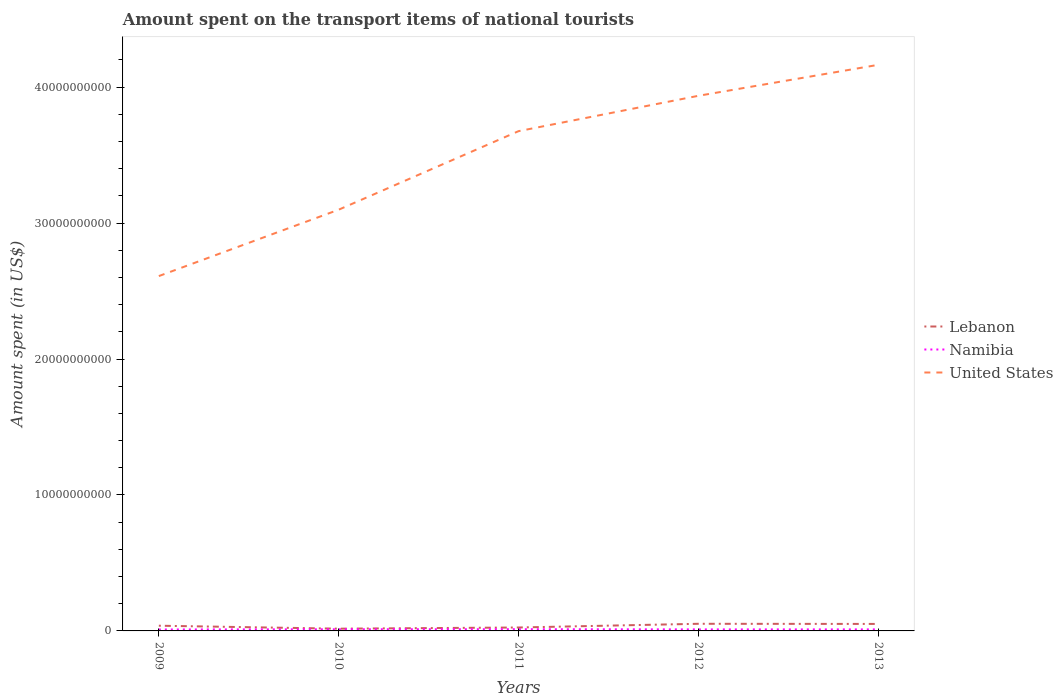Across all years, what is the maximum amount spent on the transport items of national tourists in Namibia?
Offer a very short reply. 1.06e+08. In which year was the amount spent on the transport items of national tourists in United States maximum?
Ensure brevity in your answer.  2009. What is the total amount spent on the transport items of national tourists in United States in the graph?
Offer a terse response. -1.07e+1. What is the difference between the highest and the second highest amount spent on the transport items of national tourists in Namibia?
Give a very brief answer. 2.10e+07. What is the difference between the highest and the lowest amount spent on the transport items of national tourists in United States?
Ensure brevity in your answer.  3. Is the amount spent on the transport items of national tourists in Lebanon strictly greater than the amount spent on the transport items of national tourists in United States over the years?
Make the answer very short. Yes. Are the values on the major ticks of Y-axis written in scientific E-notation?
Your response must be concise. No. Does the graph contain grids?
Make the answer very short. No. How are the legend labels stacked?
Your answer should be very brief. Vertical. What is the title of the graph?
Provide a short and direct response. Amount spent on the transport items of national tourists. Does "Somalia" appear as one of the legend labels in the graph?
Give a very brief answer. No. What is the label or title of the Y-axis?
Provide a succinct answer. Amount spent (in US$). What is the Amount spent (in US$) in Lebanon in 2009?
Give a very brief answer. 3.83e+08. What is the Amount spent (in US$) in Namibia in 2009?
Ensure brevity in your answer.  1.06e+08. What is the Amount spent (in US$) in United States in 2009?
Your answer should be very brief. 2.61e+1. What is the Amount spent (in US$) of Lebanon in 2010?
Your answer should be very brief. 1.65e+08. What is the Amount spent (in US$) in Namibia in 2010?
Ensure brevity in your answer.  1.21e+08. What is the Amount spent (in US$) in United States in 2010?
Your answer should be compact. 3.10e+1. What is the Amount spent (in US$) of Lebanon in 2011?
Offer a terse response. 2.52e+08. What is the Amount spent (in US$) of Namibia in 2011?
Your answer should be compact. 1.27e+08. What is the Amount spent (in US$) of United States in 2011?
Your response must be concise. 3.68e+1. What is the Amount spent (in US$) of Lebanon in 2012?
Give a very brief answer. 5.25e+08. What is the Amount spent (in US$) in Namibia in 2012?
Keep it short and to the point. 1.13e+08. What is the Amount spent (in US$) of United States in 2012?
Your answer should be very brief. 3.94e+1. What is the Amount spent (in US$) of Lebanon in 2013?
Offer a very short reply. 5.14e+08. What is the Amount spent (in US$) of Namibia in 2013?
Provide a short and direct response. 1.13e+08. What is the Amount spent (in US$) of United States in 2013?
Ensure brevity in your answer.  4.16e+1. Across all years, what is the maximum Amount spent (in US$) in Lebanon?
Keep it short and to the point. 5.25e+08. Across all years, what is the maximum Amount spent (in US$) of Namibia?
Your response must be concise. 1.27e+08. Across all years, what is the maximum Amount spent (in US$) in United States?
Give a very brief answer. 4.16e+1. Across all years, what is the minimum Amount spent (in US$) in Lebanon?
Your response must be concise. 1.65e+08. Across all years, what is the minimum Amount spent (in US$) in Namibia?
Provide a succinct answer. 1.06e+08. Across all years, what is the minimum Amount spent (in US$) of United States?
Keep it short and to the point. 2.61e+1. What is the total Amount spent (in US$) of Lebanon in the graph?
Ensure brevity in your answer.  1.84e+09. What is the total Amount spent (in US$) of Namibia in the graph?
Keep it short and to the point. 5.80e+08. What is the total Amount spent (in US$) of United States in the graph?
Your answer should be very brief. 1.75e+11. What is the difference between the Amount spent (in US$) in Lebanon in 2009 and that in 2010?
Offer a terse response. 2.18e+08. What is the difference between the Amount spent (in US$) of Namibia in 2009 and that in 2010?
Offer a terse response. -1.50e+07. What is the difference between the Amount spent (in US$) in United States in 2009 and that in 2010?
Provide a succinct answer. -4.88e+09. What is the difference between the Amount spent (in US$) of Lebanon in 2009 and that in 2011?
Keep it short and to the point. 1.31e+08. What is the difference between the Amount spent (in US$) of Namibia in 2009 and that in 2011?
Offer a very short reply. -2.10e+07. What is the difference between the Amount spent (in US$) in United States in 2009 and that in 2011?
Provide a succinct answer. -1.07e+1. What is the difference between the Amount spent (in US$) in Lebanon in 2009 and that in 2012?
Provide a succinct answer. -1.42e+08. What is the difference between the Amount spent (in US$) in Namibia in 2009 and that in 2012?
Provide a short and direct response. -7.00e+06. What is the difference between the Amount spent (in US$) in United States in 2009 and that in 2012?
Offer a very short reply. -1.33e+1. What is the difference between the Amount spent (in US$) of Lebanon in 2009 and that in 2013?
Provide a short and direct response. -1.31e+08. What is the difference between the Amount spent (in US$) in Namibia in 2009 and that in 2013?
Ensure brevity in your answer.  -7.00e+06. What is the difference between the Amount spent (in US$) in United States in 2009 and that in 2013?
Ensure brevity in your answer.  -1.55e+1. What is the difference between the Amount spent (in US$) of Lebanon in 2010 and that in 2011?
Your answer should be very brief. -8.70e+07. What is the difference between the Amount spent (in US$) of Namibia in 2010 and that in 2011?
Your response must be concise. -6.00e+06. What is the difference between the Amount spent (in US$) of United States in 2010 and that in 2011?
Offer a terse response. -5.78e+09. What is the difference between the Amount spent (in US$) of Lebanon in 2010 and that in 2012?
Your answer should be very brief. -3.60e+08. What is the difference between the Amount spent (in US$) of United States in 2010 and that in 2012?
Your answer should be compact. -8.38e+09. What is the difference between the Amount spent (in US$) of Lebanon in 2010 and that in 2013?
Provide a succinct answer. -3.49e+08. What is the difference between the Amount spent (in US$) in United States in 2010 and that in 2013?
Offer a very short reply. -1.07e+1. What is the difference between the Amount spent (in US$) of Lebanon in 2011 and that in 2012?
Your answer should be very brief. -2.73e+08. What is the difference between the Amount spent (in US$) of Namibia in 2011 and that in 2012?
Your response must be concise. 1.40e+07. What is the difference between the Amount spent (in US$) in United States in 2011 and that in 2012?
Your answer should be very brief. -2.60e+09. What is the difference between the Amount spent (in US$) of Lebanon in 2011 and that in 2013?
Offer a terse response. -2.62e+08. What is the difference between the Amount spent (in US$) of Namibia in 2011 and that in 2013?
Keep it short and to the point. 1.40e+07. What is the difference between the Amount spent (in US$) in United States in 2011 and that in 2013?
Offer a very short reply. -4.88e+09. What is the difference between the Amount spent (in US$) in Lebanon in 2012 and that in 2013?
Ensure brevity in your answer.  1.10e+07. What is the difference between the Amount spent (in US$) of United States in 2012 and that in 2013?
Ensure brevity in your answer.  -2.28e+09. What is the difference between the Amount spent (in US$) of Lebanon in 2009 and the Amount spent (in US$) of Namibia in 2010?
Give a very brief answer. 2.62e+08. What is the difference between the Amount spent (in US$) in Lebanon in 2009 and the Amount spent (in US$) in United States in 2010?
Your answer should be very brief. -3.06e+1. What is the difference between the Amount spent (in US$) of Namibia in 2009 and the Amount spent (in US$) of United States in 2010?
Give a very brief answer. -3.09e+1. What is the difference between the Amount spent (in US$) in Lebanon in 2009 and the Amount spent (in US$) in Namibia in 2011?
Ensure brevity in your answer.  2.56e+08. What is the difference between the Amount spent (in US$) of Lebanon in 2009 and the Amount spent (in US$) of United States in 2011?
Make the answer very short. -3.64e+1. What is the difference between the Amount spent (in US$) of Namibia in 2009 and the Amount spent (in US$) of United States in 2011?
Your response must be concise. -3.67e+1. What is the difference between the Amount spent (in US$) in Lebanon in 2009 and the Amount spent (in US$) in Namibia in 2012?
Provide a short and direct response. 2.70e+08. What is the difference between the Amount spent (in US$) in Lebanon in 2009 and the Amount spent (in US$) in United States in 2012?
Offer a terse response. -3.90e+1. What is the difference between the Amount spent (in US$) in Namibia in 2009 and the Amount spent (in US$) in United States in 2012?
Make the answer very short. -3.93e+1. What is the difference between the Amount spent (in US$) of Lebanon in 2009 and the Amount spent (in US$) of Namibia in 2013?
Give a very brief answer. 2.70e+08. What is the difference between the Amount spent (in US$) in Lebanon in 2009 and the Amount spent (in US$) in United States in 2013?
Offer a terse response. -4.13e+1. What is the difference between the Amount spent (in US$) in Namibia in 2009 and the Amount spent (in US$) in United States in 2013?
Provide a short and direct response. -4.15e+1. What is the difference between the Amount spent (in US$) of Lebanon in 2010 and the Amount spent (in US$) of Namibia in 2011?
Keep it short and to the point. 3.80e+07. What is the difference between the Amount spent (in US$) of Lebanon in 2010 and the Amount spent (in US$) of United States in 2011?
Make the answer very short. -3.66e+1. What is the difference between the Amount spent (in US$) of Namibia in 2010 and the Amount spent (in US$) of United States in 2011?
Keep it short and to the point. -3.66e+1. What is the difference between the Amount spent (in US$) of Lebanon in 2010 and the Amount spent (in US$) of Namibia in 2012?
Your answer should be very brief. 5.20e+07. What is the difference between the Amount spent (in US$) of Lebanon in 2010 and the Amount spent (in US$) of United States in 2012?
Your answer should be very brief. -3.92e+1. What is the difference between the Amount spent (in US$) of Namibia in 2010 and the Amount spent (in US$) of United States in 2012?
Your response must be concise. -3.92e+1. What is the difference between the Amount spent (in US$) in Lebanon in 2010 and the Amount spent (in US$) in Namibia in 2013?
Make the answer very short. 5.20e+07. What is the difference between the Amount spent (in US$) in Lebanon in 2010 and the Amount spent (in US$) in United States in 2013?
Make the answer very short. -4.15e+1. What is the difference between the Amount spent (in US$) of Namibia in 2010 and the Amount spent (in US$) of United States in 2013?
Offer a terse response. -4.15e+1. What is the difference between the Amount spent (in US$) of Lebanon in 2011 and the Amount spent (in US$) of Namibia in 2012?
Provide a short and direct response. 1.39e+08. What is the difference between the Amount spent (in US$) of Lebanon in 2011 and the Amount spent (in US$) of United States in 2012?
Provide a succinct answer. -3.91e+1. What is the difference between the Amount spent (in US$) of Namibia in 2011 and the Amount spent (in US$) of United States in 2012?
Make the answer very short. -3.92e+1. What is the difference between the Amount spent (in US$) of Lebanon in 2011 and the Amount spent (in US$) of Namibia in 2013?
Offer a terse response. 1.39e+08. What is the difference between the Amount spent (in US$) in Lebanon in 2011 and the Amount spent (in US$) in United States in 2013?
Your answer should be very brief. -4.14e+1. What is the difference between the Amount spent (in US$) of Namibia in 2011 and the Amount spent (in US$) of United States in 2013?
Keep it short and to the point. -4.15e+1. What is the difference between the Amount spent (in US$) of Lebanon in 2012 and the Amount spent (in US$) of Namibia in 2013?
Your response must be concise. 4.12e+08. What is the difference between the Amount spent (in US$) in Lebanon in 2012 and the Amount spent (in US$) in United States in 2013?
Provide a short and direct response. -4.11e+1. What is the difference between the Amount spent (in US$) of Namibia in 2012 and the Amount spent (in US$) of United States in 2013?
Offer a terse response. -4.15e+1. What is the average Amount spent (in US$) of Lebanon per year?
Make the answer very short. 3.68e+08. What is the average Amount spent (in US$) in Namibia per year?
Offer a terse response. 1.16e+08. What is the average Amount spent (in US$) of United States per year?
Keep it short and to the point. 3.50e+1. In the year 2009, what is the difference between the Amount spent (in US$) in Lebanon and Amount spent (in US$) in Namibia?
Offer a very short reply. 2.77e+08. In the year 2009, what is the difference between the Amount spent (in US$) in Lebanon and Amount spent (in US$) in United States?
Offer a terse response. -2.57e+1. In the year 2009, what is the difference between the Amount spent (in US$) of Namibia and Amount spent (in US$) of United States?
Your answer should be compact. -2.60e+1. In the year 2010, what is the difference between the Amount spent (in US$) in Lebanon and Amount spent (in US$) in Namibia?
Your response must be concise. 4.40e+07. In the year 2010, what is the difference between the Amount spent (in US$) of Lebanon and Amount spent (in US$) of United States?
Your answer should be compact. -3.08e+1. In the year 2010, what is the difference between the Amount spent (in US$) of Namibia and Amount spent (in US$) of United States?
Provide a short and direct response. -3.09e+1. In the year 2011, what is the difference between the Amount spent (in US$) in Lebanon and Amount spent (in US$) in Namibia?
Provide a short and direct response. 1.25e+08. In the year 2011, what is the difference between the Amount spent (in US$) in Lebanon and Amount spent (in US$) in United States?
Provide a succinct answer. -3.65e+1. In the year 2011, what is the difference between the Amount spent (in US$) in Namibia and Amount spent (in US$) in United States?
Provide a succinct answer. -3.66e+1. In the year 2012, what is the difference between the Amount spent (in US$) in Lebanon and Amount spent (in US$) in Namibia?
Your answer should be compact. 4.12e+08. In the year 2012, what is the difference between the Amount spent (in US$) in Lebanon and Amount spent (in US$) in United States?
Your response must be concise. -3.88e+1. In the year 2012, what is the difference between the Amount spent (in US$) of Namibia and Amount spent (in US$) of United States?
Make the answer very short. -3.93e+1. In the year 2013, what is the difference between the Amount spent (in US$) of Lebanon and Amount spent (in US$) of Namibia?
Provide a short and direct response. 4.01e+08. In the year 2013, what is the difference between the Amount spent (in US$) of Lebanon and Amount spent (in US$) of United States?
Give a very brief answer. -4.11e+1. In the year 2013, what is the difference between the Amount spent (in US$) in Namibia and Amount spent (in US$) in United States?
Provide a succinct answer. -4.15e+1. What is the ratio of the Amount spent (in US$) in Lebanon in 2009 to that in 2010?
Make the answer very short. 2.32. What is the ratio of the Amount spent (in US$) in Namibia in 2009 to that in 2010?
Your answer should be very brief. 0.88. What is the ratio of the Amount spent (in US$) in United States in 2009 to that in 2010?
Keep it short and to the point. 0.84. What is the ratio of the Amount spent (in US$) in Lebanon in 2009 to that in 2011?
Your answer should be very brief. 1.52. What is the ratio of the Amount spent (in US$) of Namibia in 2009 to that in 2011?
Your answer should be compact. 0.83. What is the ratio of the Amount spent (in US$) in United States in 2009 to that in 2011?
Provide a short and direct response. 0.71. What is the ratio of the Amount spent (in US$) of Lebanon in 2009 to that in 2012?
Provide a short and direct response. 0.73. What is the ratio of the Amount spent (in US$) of Namibia in 2009 to that in 2012?
Offer a terse response. 0.94. What is the ratio of the Amount spent (in US$) in United States in 2009 to that in 2012?
Keep it short and to the point. 0.66. What is the ratio of the Amount spent (in US$) of Lebanon in 2009 to that in 2013?
Ensure brevity in your answer.  0.75. What is the ratio of the Amount spent (in US$) in Namibia in 2009 to that in 2013?
Provide a short and direct response. 0.94. What is the ratio of the Amount spent (in US$) in United States in 2009 to that in 2013?
Your response must be concise. 0.63. What is the ratio of the Amount spent (in US$) of Lebanon in 2010 to that in 2011?
Ensure brevity in your answer.  0.65. What is the ratio of the Amount spent (in US$) in Namibia in 2010 to that in 2011?
Your response must be concise. 0.95. What is the ratio of the Amount spent (in US$) in United States in 2010 to that in 2011?
Your answer should be very brief. 0.84. What is the ratio of the Amount spent (in US$) in Lebanon in 2010 to that in 2012?
Give a very brief answer. 0.31. What is the ratio of the Amount spent (in US$) in Namibia in 2010 to that in 2012?
Your answer should be very brief. 1.07. What is the ratio of the Amount spent (in US$) in United States in 2010 to that in 2012?
Ensure brevity in your answer.  0.79. What is the ratio of the Amount spent (in US$) in Lebanon in 2010 to that in 2013?
Your response must be concise. 0.32. What is the ratio of the Amount spent (in US$) in Namibia in 2010 to that in 2013?
Your answer should be compact. 1.07. What is the ratio of the Amount spent (in US$) of United States in 2010 to that in 2013?
Your answer should be compact. 0.74. What is the ratio of the Amount spent (in US$) of Lebanon in 2011 to that in 2012?
Keep it short and to the point. 0.48. What is the ratio of the Amount spent (in US$) of Namibia in 2011 to that in 2012?
Provide a short and direct response. 1.12. What is the ratio of the Amount spent (in US$) of United States in 2011 to that in 2012?
Offer a terse response. 0.93. What is the ratio of the Amount spent (in US$) in Lebanon in 2011 to that in 2013?
Ensure brevity in your answer.  0.49. What is the ratio of the Amount spent (in US$) in Namibia in 2011 to that in 2013?
Your answer should be compact. 1.12. What is the ratio of the Amount spent (in US$) of United States in 2011 to that in 2013?
Your response must be concise. 0.88. What is the ratio of the Amount spent (in US$) of Lebanon in 2012 to that in 2013?
Your answer should be very brief. 1.02. What is the ratio of the Amount spent (in US$) of United States in 2012 to that in 2013?
Provide a succinct answer. 0.95. What is the difference between the highest and the second highest Amount spent (in US$) in Lebanon?
Provide a succinct answer. 1.10e+07. What is the difference between the highest and the second highest Amount spent (in US$) in United States?
Your response must be concise. 2.28e+09. What is the difference between the highest and the lowest Amount spent (in US$) in Lebanon?
Provide a succinct answer. 3.60e+08. What is the difference between the highest and the lowest Amount spent (in US$) of Namibia?
Offer a very short reply. 2.10e+07. What is the difference between the highest and the lowest Amount spent (in US$) in United States?
Your answer should be very brief. 1.55e+1. 